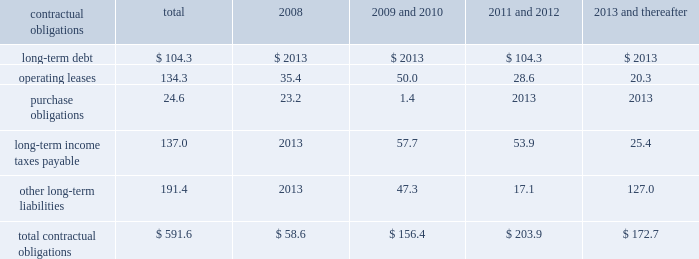Customary affirmative and negative covenants and events of default for an unsecured financing arrangement , including , among other things , limitations on consolidations , mergers and sales of assets .
Financial covenants include a maximum leverage ratio of 3.0 to 1.0 and a minimum interest coverage ratio of 3.5 to 1.0 .
If we fall below an investment grade credit rating , additional restrictions would result , including restrictions on investments , payment of dividends and stock repurchases .
We were in compliance with all covenants under the senior credit facility as of december 31 , 2007 .
Commitments under the senior credit facility are subject to certain fees , including a facility and a utilization fee .
The senior credit facility is rated a- by standard & poor 2019s ratings services and is not rated by moody 2019s investors 2019 service , inc .
We also have available uncommitted credit facilities totaling $ 70.4 million .
Management believes that cash flows from operations , together with available borrowings under the senior credit facility , are sufficient to meet our expected working capital , capital expenditure and debt service needs .
Should investment opportunities arise , we believe that our earnings , balance sheet and cash flows will allow us to obtain additional capital , if necessary .
Contractual obligations we have entered into contracts with various third parties in the normal course of business which will require future payments .
The table illustrates our contractual obligations ( in millions ) : contractual obligations total 2008 thereafter .
Total contractual obligations $ 591.6 $ 58.6 $ 156.4 $ 203.9 $ 172.7 critical accounting estimates our financial results are affected by the selection and application of accounting policies and methods .
Significant accounting policies which require management 2019s judgment are discussed below .
Excess inventory and instruments 2013 we must determine as of each balance sheet date how much , if any , of our inventory may ultimately prove to be unsaleable or unsaleable at our carrying cost .
Similarly , we must also determine if instruments on hand will be put to productive use or remain undeployed as a result of excess supply .
Reserves are established to effectively adjust inventory and instruments to net realizable value .
To determine the appropriate level of reserves , we evaluate current stock levels in relation to historical and expected patterns of demand for all of our products and instrument systems and components .
The basis for the determination is generally the same for all inventory and instrument items and categories except for work-in-progress inventory , which is recorded at cost .
Obsolete or discontinued items are generally destroyed and completely written off .
Management evaluates the need for changes to valuation reserves based on market conditions , competitive offerings and other factors on a regular basis .
Income taxes fffd we estimate income tax expense and income tax liabilities and assets by taxable jurisdiction .
Realization of deferred tax assets in each taxable jurisdiction is dependent on our ability to generate future taxable income sufficient to realize the benefits .
We evaluate deferred tax assets on an ongoing basis and provide valuation allowances if it is determined to be 201cmore likely than not 201d that the deferred tax benefit will not be realized .
Federal income taxes are provided on the portion of the income of foreign subsidiaries that is expected to be remitted to the u.s .
We operate within numerous taxing jurisdictions .
We are subject to regulatory review or audit in virtually all of those jurisdictions and those reviews and audits may require extended periods of time to resolve .
We make use of all available information and make reasoned judgments regarding matters requiring interpretation in establishing tax expense , liabilities and reserves .
We believe adequate provisions exist for income taxes for all periods and jurisdictions subject to review or audit .
Commitments and contingencies 2013 accruals for product liability and other claims are established with internal and external legal counsel based on current information and historical settlement information for claims , related fees and for claims incurred but not reported .
We use an actuarial model to assist management in determining an appropriate level of accruals for product liability claims .
Historical patterns of claim loss development over time are statistically analyzed to arrive at factors which are then applied to loss estimates in the actuarial model .
The amounts established equate to less than 5 percent of total liabilities and represent management 2019s best estimate of the ultimate costs that we will incur under the various contingencies .
Goodwill and intangible assets 2013 we evaluate the carrying value of goodwill and indefinite life intangible assets annually , or whenever events or circumstances indicate the carrying value may not be recoverable .
We evaluate the carrying value of finite life intangible assets whenever events or circumstances indicate the carrying value may not be recoverable .
Significant assumptions are required to estimate the fair value of goodwill and intangible assets , most notably estimated future cash flows generated by these assets .
As such , these fair valuation measurements use significant unobservable inputs as defined under statement of financial accounting standards no .
157 , fair value measurements .
Changes to these assumptions could require us to record impairment charges on these assets .
Share-based payment 2013 we account for share-based payment expense in accordance with the fair value z i m m e r h o l d i n g s , i n c .
2 0 0 7 f o r m 1 0 - k a n n u a l r e p o r t .
What percentage of total contractual obligations is operating leases? 
Computations: (134.3 / 591.6)
Answer: 0.22701. Customary affirmative and negative covenants and events of default for an unsecured financing arrangement , including , among other things , limitations on consolidations , mergers and sales of assets .
Financial covenants include a maximum leverage ratio of 3.0 to 1.0 and a minimum interest coverage ratio of 3.5 to 1.0 .
If we fall below an investment grade credit rating , additional restrictions would result , including restrictions on investments , payment of dividends and stock repurchases .
We were in compliance with all covenants under the senior credit facility as of december 31 , 2007 .
Commitments under the senior credit facility are subject to certain fees , including a facility and a utilization fee .
The senior credit facility is rated a- by standard & poor 2019s ratings services and is not rated by moody 2019s investors 2019 service , inc .
We also have available uncommitted credit facilities totaling $ 70.4 million .
Management believes that cash flows from operations , together with available borrowings under the senior credit facility , are sufficient to meet our expected working capital , capital expenditure and debt service needs .
Should investment opportunities arise , we believe that our earnings , balance sheet and cash flows will allow us to obtain additional capital , if necessary .
Contractual obligations we have entered into contracts with various third parties in the normal course of business which will require future payments .
The table illustrates our contractual obligations ( in millions ) : contractual obligations total 2008 thereafter .
Total contractual obligations $ 591.6 $ 58.6 $ 156.4 $ 203.9 $ 172.7 critical accounting estimates our financial results are affected by the selection and application of accounting policies and methods .
Significant accounting policies which require management 2019s judgment are discussed below .
Excess inventory and instruments 2013 we must determine as of each balance sheet date how much , if any , of our inventory may ultimately prove to be unsaleable or unsaleable at our carrying cost .
Similarly , we must also determine if instruments on hand will be put to productive use or remain undeployed as a result of excess supply .
Reserves are established to effectively adjust inventory and instruments to net realizable value .
To determine the appropriate level of reserves , we evaluate current stock levels in relation to historical and expected patterns of demand for all of our products and instrument systems and components .
The basis for the determination is generally the same for all inventory and instrument items and categories except for work-in-progress inventory , which is recorded at cost .
Obsolete or discontinued items are generally destroyed and completely written off .
Management evaluates the need for changes to valuation reserves based on market conditions , competitive offerings and other factors on a regular basis .
Income taxes fffd we estimate income tax expense and income tax liabilities and assets by taxable jurisdiction .
Realization of deferred tax assets in each taxable jurisdiction is dependent on our ability to generate future taxable income sufficient to realize the benefits .
We evaluate deferred tax assets on an ongoing basis and provide valuation allowances if it is determined to be 201cmore likely than not 201d that the deferred tax benefit will not be realized .
Federal income taxes are provided on the portion of the income of foreign subsidiaries that is expected to be remitted to the u.s .
We operate within numerous taxing jurisdictions .
We are subject to regulatory review or audit in virtually all of those jurisdictions and those reviews and audits may require extended periods of time to resolve .
We make use of all available information and make reasoned judgments regarding matters requiring interpretation in establishing tax expense , liabilities and reserves .
We believe adequate provisions exist for income taxes for all periods and jurisdictions subject to review or audit .
Commitments and contingencies 2013 accruals for product liability and other claims are established with internal and external legal counsel based on current information and historical settlement information for claims , related fees and for claims incurred but not reported .
We use an actuarial model to assist management in determining an appropriate level of accruals for product liability claims .
Historical patterns of claim loss development over time are statistically analyzed to arrive at factors which are then applied to loss estimates in the actuarial model .
The amounts established equate to less than 5 percent of total liabilities and represent management 2019s best estimate of the ultimate costs that we will incur under the various contingencies .
Goodwill and intangible assets 2013 we evaluate the carrying value of goodwill and indefinite life intangible assets annually , or whenever events or circumstances indicate the carrying value may not be recoverable .
We evaluate the carrying value of finite life intangible assets whenever events or circumstances indicate the carrying value may not be recoverable .
Significant assumptions are required to estimate the fair value of goodwill and intangible assets , most notably estimated future cash flows generated by these assets .
As such , these fair valuation measurements use significant unobservable inputs as defined under statement of financial accounting standards no .
157 , fair value measurements .
Changes to these assumptions could require us to record impairment charges on these assets .
Share-based payment 2013 we account for share-based payment expense in accordance with the fair value z i m m e r h o l d i n g s , i n c .
2 0 0 7 f o r m 1 0 - k a n n u a l r e p o r t .
What percent of contractual obligations is long term debt? 
Computations: (104.3 / 591.6)
Answer: 0.1763. 